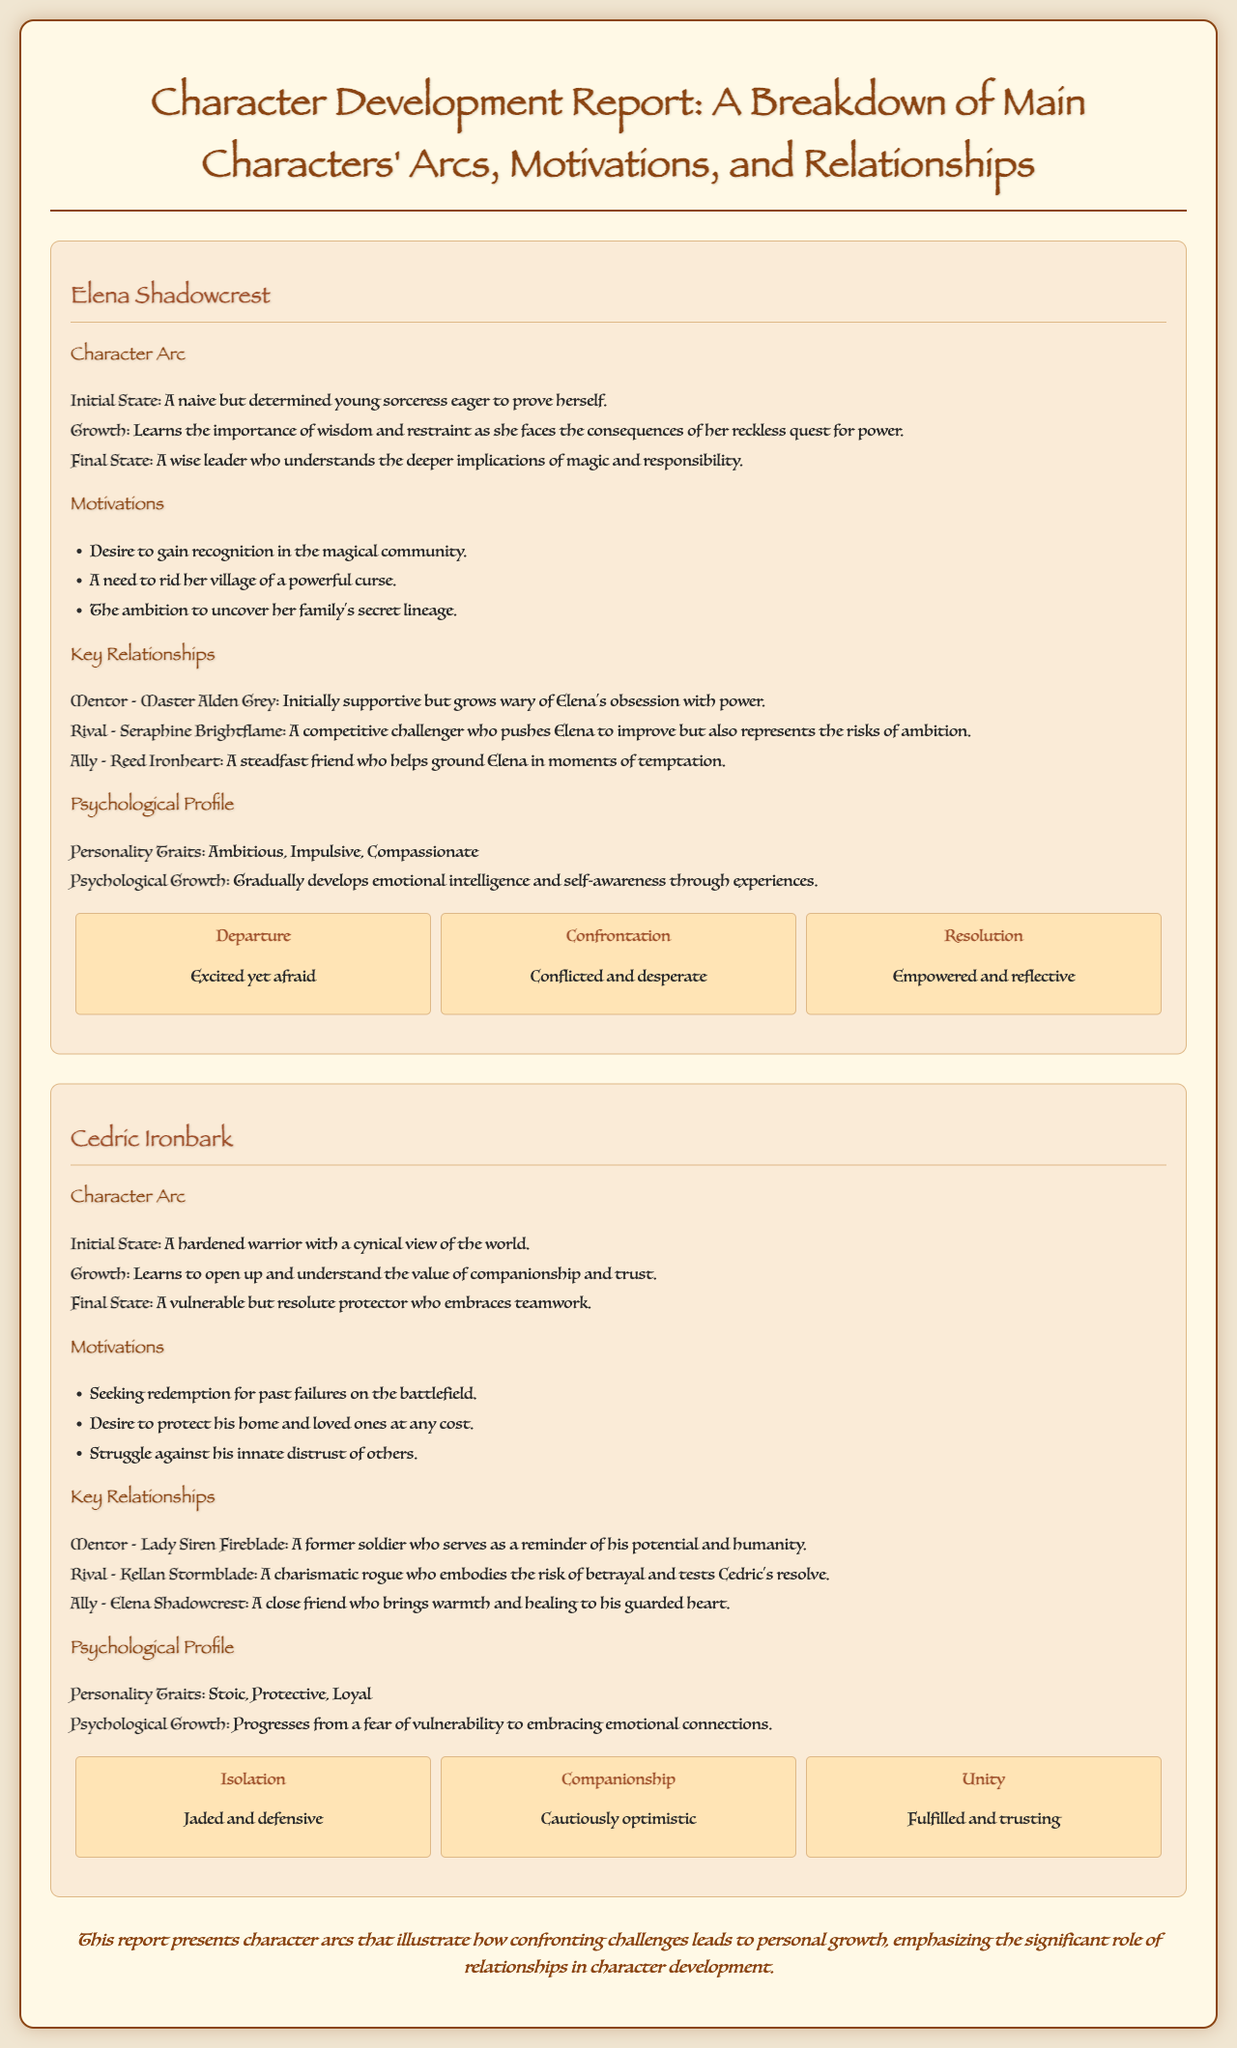What is Elena's initial state? Elena's initial state is described as a naive but determined young sorceress eager to prove herself.
Answer: A naive but determined young sorceress eager to prove herself What motivates Cedric Ironbark the most? Cedric's motivations include seeking redemption for past failures on the battlefield, indicating his primary drive for his character arc.
Answer: Seeking redemption for past failures on the battlefield Who is Elena’s mentor? The document states that Elena's mentor is Master Alden Grey, who plays a significant role in her character development.
Answer: Master Alden Grey What is the final state of Cedric Ironbark? The document outlines that Cedric's final state is a vulnerable but resolute protector who embraces teamwork.
Answer: A vulnerable but resolute protector who embraces teamwork What stage represents Elena's emotional growth during confrontation? The stage referred to as "Confrontation" highlights Elena's conflicted and desperate emotional state.
Answer: Conflicted and desperate How does Elena's character growth reflect her relationship with Reed Ironheart? Reed Ironheart is described as a steadfast friend who helps ground Elena, indicating the positive impact of their relationship on her growth.
Answer: Helps ground Elena in moments of temptation What is the psychological growth of Cedric Ironbark? Cedric's psychological growth is characterized by his progression from a fear of vulnerability to embracing emotional connections.
Answer: Progresses from a fear of vulnerability to embracing emotional connections How many key relationships does Elena have outlined in the document? The document identifies three key relationships for Elena, which are critical to understanding her character arc.
Answer: Three What emotion does Cedric experience during the "Isolation" stage? The document notes that during the "Isolation" stage, Cedric is described as jaded and defensive, capturing his emotional state.
Answer: Jaded and defensive 